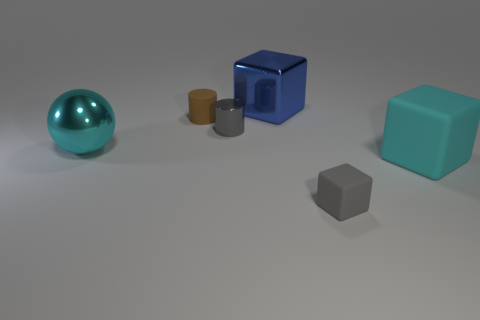Subtract all big blocks. How many blocks are left? 1 Add 2 large cyan shiny balls. How many objects exist? 8 Subtract all blue blocks. How many blocks are left? 2 Subtract 1 blocks. How many blocks are left? 2 Subtract all cylinders. How many objects are left? 4 Subtract all cyan blocks. Subtract all brown spheres. How many blocks are left? 2 Subtract all tiny cyan rubber cubes. Subtract all cyan cubes. How many objects are left? 5 Add 4 gray objects. How many gray objects are left? 6 Add 6 cyan cylinders. How many cyan cylinders exist? 6 Subtract 0 yellow balls. How many objects are left? 6 